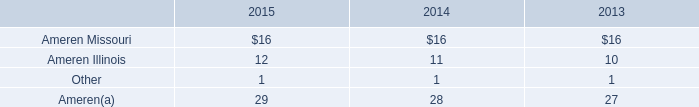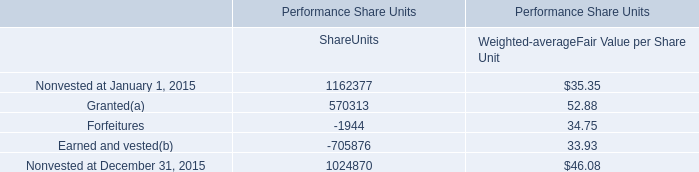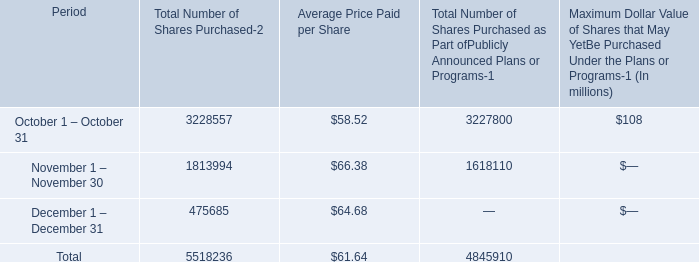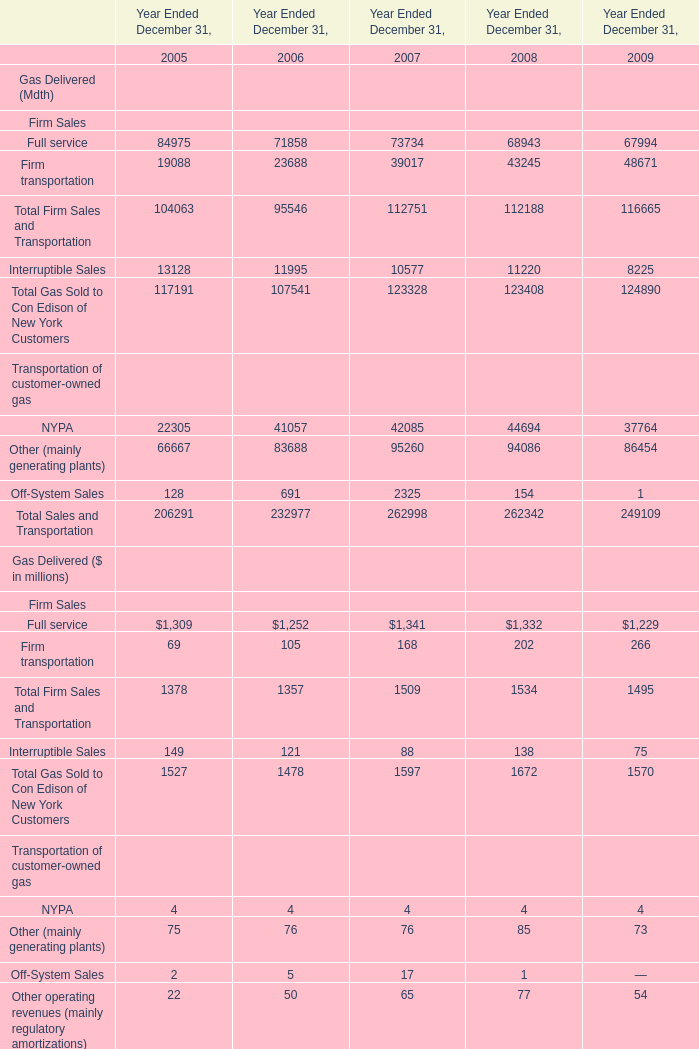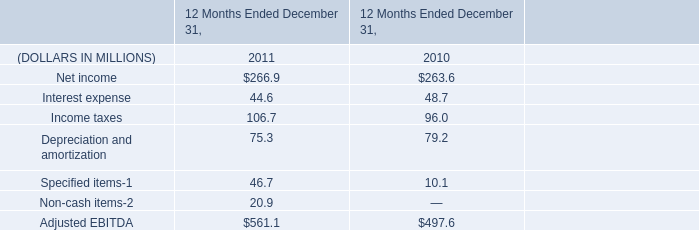What is the ratio of Firm transportation to the total in 2005 and 2006? 
Computations: (19088 / (19088 + 23688))
Answer: 0.44623. 